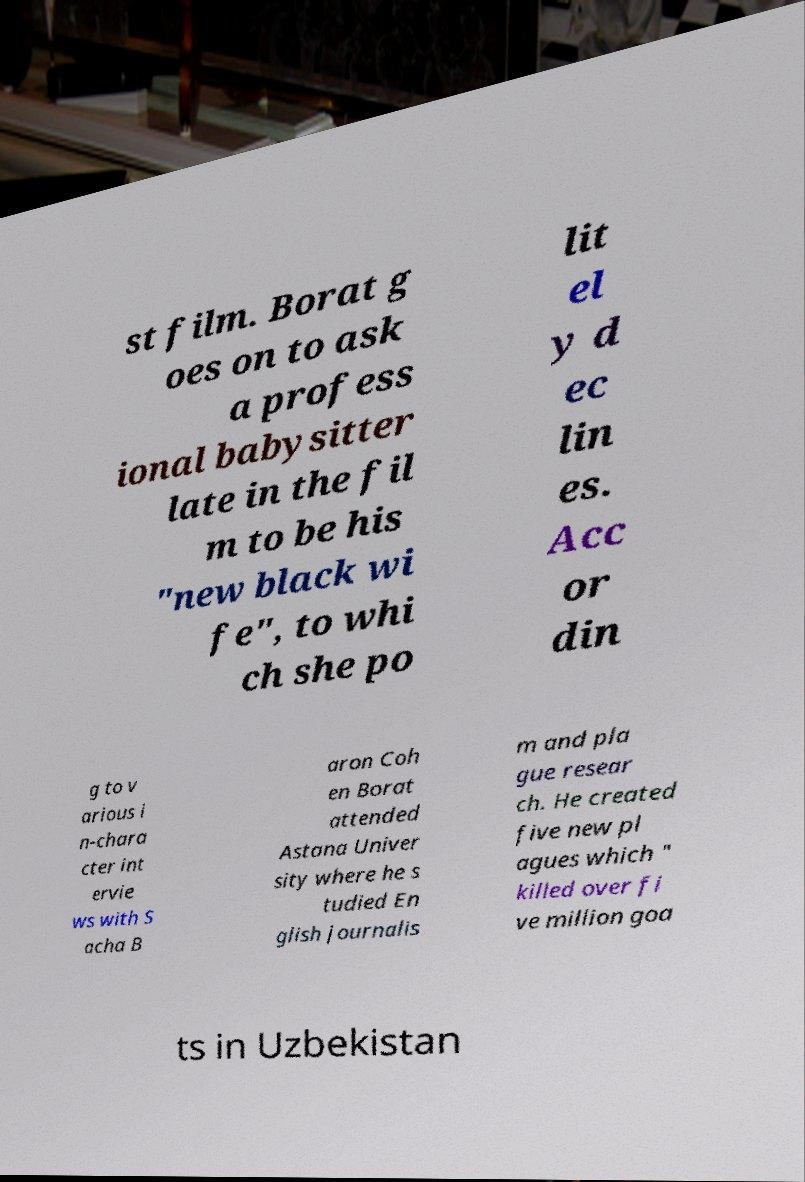Can you read and provide the text displayed in the image?This photo seems to have some interesting text. Can you extract and type it out for me? st film. Borat g oes on to ask a profess ional babysitter late in the fil m to be his "new black wi fe", to whi ch she po lit el y d ec lin es. Acc or din g to v arious i n-chara cter int ervie ws with S acha B aron Coh en Borat attended Astana Univer sity where he s tudied En glish journalis m and pla gue resear ch. He created five new pl agues which " killed over fi ve million goa ts in Uzbekistan 